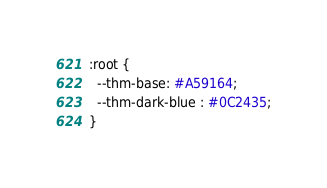<code> <loc_0><loc_0><loc_500><loc_500><_CSS_>:root {
  --thm-base: #A59164;
  --thm-dark-blue : #0C2435;
}
</code> 